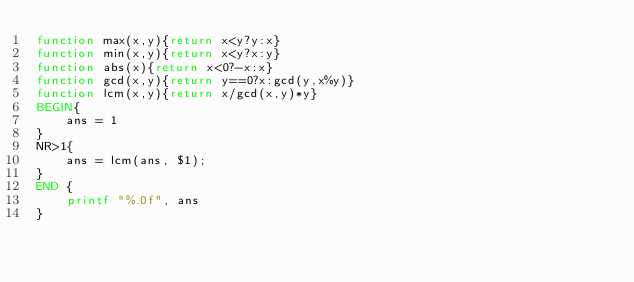Convert code to text. <code><loc_0><loc_0><loc_500><loc_500><_Awk_>function max(x,y){return x<y?y:x}
function min(x,y){return x<y?x:y}
function abs(x){return x<0?-x:x}
function gcd(x,y){return y==0?x:gcd(y,x%y)}
function lcm(x,y){return x/gcd(x,y)*y}
BEGIN{
    ans = 1
}
NR>1{
    ans = lcm(ans, $1);
}
END {
    printf "%.0f", ans
}
</code> 